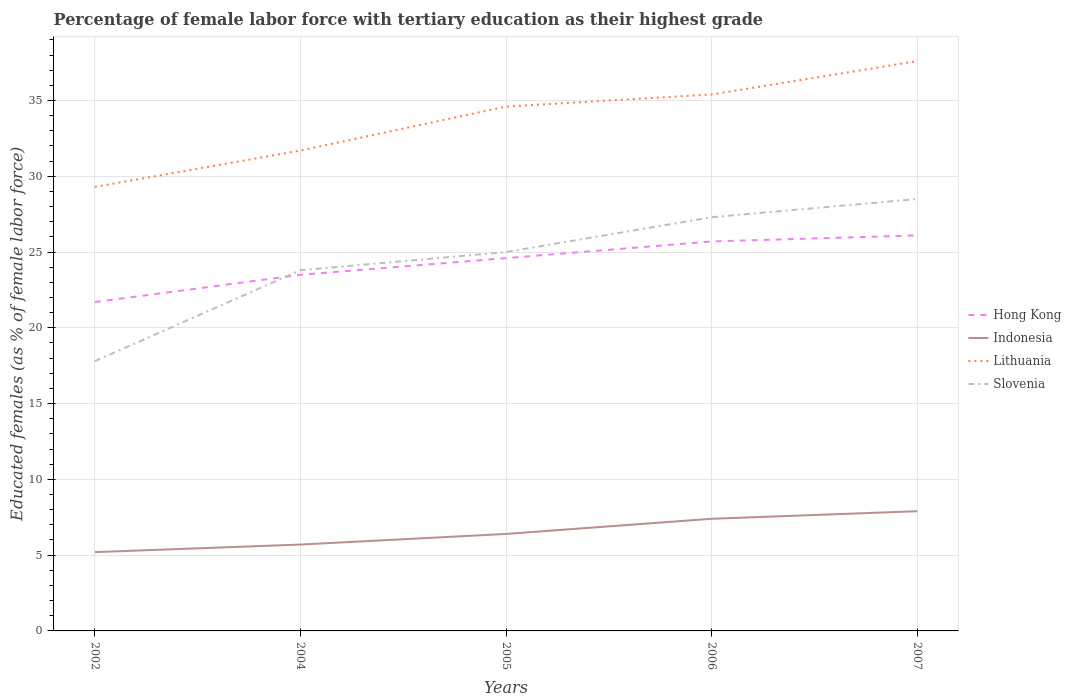How many different coloured lines are there?
Make the answer very short. 4. Does the line corresponding to Lithuania intersect with the line corresponding to Hong Kong?
Make the answer very short. No. Across all years, what is the maximum percentage of female labor force with tertiary education in Slovenia?
Give a very brief answer. 17.8. In which year was the percentage of female labor force with tertiary education in Lithuania maximum?
Your response must be concise. 2002. What is the total percentage of female labor force with tertiary education in Hong Kong in the graph?
Ensure brevity in your answer.  -1.8. What is the difference between the highest and the second highest percentage of female labor force with tertiary education in Hong Kong?
Ensure brevity in your answer.  4.4. Is the percentage of female labor force with tertiary education in Hong Kong strictly greater than the percentage of female labor force with tertiary education in Lithuania over the years?
Your response must be concise. Yes. Are the values on the major ticks of Y-axis written in scientific E-notation?
Make the answer very short. No. Does the graph contain any zero values?
Your response must be concise. No. Where does the legend appear in the graph?
Your answer should be very brief. Center right. How many legend labels are there?
Give a very brief answer. 4. What is the title of the graph?
Provide a short and direct response. Percentage of female labor force with tertiary education as their highest grade. Does "Malaysia" appear as one of the legend labels in the graph?
Ensure brevity in your answer.  No. What is the label or title of the Y-axis?
Provide a succinct answer. Educated females (as % of female labor force). What is the Educated females (as % of female labor force) in Hong Kong in 2002?
Provide a succinct answer. 21.7. What is the Educated females (as % of female labor force) of Indonesia in 2002?
Offer a very short reply. 5.2. What is the Educated females (as % of female labor force) in Lithuania in 2002?
Give a very brief answer. 29.3. What is the Educated females (as % of female labor force) in Slovenia in 2002?
Your response must be concise. 17.8. What is the Educated females (as % of female labor force) in Indonesia in 2004?
Your response must be concise. 5.7. What is the Educated females (as % of female labor force) of Lithuania in 2004?
Your answer should be compact. 31.7. What is the Educated females (as % of female labor force) of Slovenia in 2004?
Provide a succinct answer. 23.8. What is the Educated females (as % of female labor force) in Hong Kong in 2005?
Give a very brief answer. 24.6. What is the Educated females (as % of female labor force) in Indonesia in 2005?
Provide a short and direct response. 6.4. What is the Educated females (as % of female labor force) of Lithuania in 2005?
Offer a very short reply. 34.6. What is the Educated females (as % of female labor force) in Hong Kong in 2006?
Offer a terse response. 25.7. What is the Educated females (as % of female labor force) of Indonesia in 2006?
Provide a succinct answer. 7.4. What is the Educated females (as % of female labor force) of Lithuania in 2006?
Offer a very short reply. 35.4. What is the Educated females (as % of female labor force) of Slovenia in 2006?
Your answer should be very brief. 27.3. What is the Educated females (as % of female labor force) of Hong Kong in 2007?
Your answer should be compact. 26.1. What is the Educated females (as % of female labor force) in Indonesia in 2007?
Your response must be concise. 7.9. What is the Educated females (as % of female labor force) of Lithuania in 2007?
Provide a succinct answer. 37.6. What is the Educated females (as % of female labor force) of Slovenia in 2007?
Your response must be concise. 28.5. Across all years, what is the maximum Educated females (as % of female labor force) in Hong Kong?
Make the answer very short. 26.1. Across all years, what is the maximum Educated females (as % of female labor force) in Indonesia?
Make the answer very short. 7.9. Across all years, what is the maximum Educated females (as % of female labor force) in Lithuania?
Ensure brevity in your answer.  37.6. Across all years, what is the minimum Educated females (as % of female labor force) in Hong Kong?
Your answer should be very brief. 21.7. Across all years, what is the minimum Educated females (as % of female labor force) in Indonesia?
Give a very brief answer. 5.2. Across all years, what is the minimum Educated females (as % of female labor force) in Lithuania?
Give a very brief answer. 29.3. Across all years, what is the minimum Educated females (as % of female labor force) of Slovenia?
Your answer should be very brief. 17.8. What is the total Educated females (as % of female labor force) in Hong Kong in the graph?
Make the answer very short. 121.6. What is the total Educated females (as % of female labor force) of Indonesia in the graph?
Keep it short and to the point. 32.6. What is the total Educated females (as % of female labor force) of Lithuania in the graph?
Offer a very short reply. 168.6. What is the total Educated females (as % of female labor force) in Slovenia in the graph?
Your answer should be compact. 122.4. What is the difference between the Educated females (as % of female labor force) in Indonesia in 2002 and that in 2004?
Your answer should be very brief. -0.5. What is the difference between the Educated females (as % of female labor force) in Slovenia in 2002 and that in 2004?
Make the answer very short. -6. What is the difference between the Educated females (as % of female labor force) in Lithuania in 2002 and that in 2005?
Provide a succinct answer. -5.3. What is the difference between the Educated females (as % of female labor force) of Slovenia in 2002 and that in 2006?
Your answer should be compact. -9.5. What is the difference between the Educated females (as % of female labor force) in Lithuania in 2002 and that in 2007?
Give a very brief answer. -8.3. What is the difference between the Educated females (as % of female labor force) in Slovenia in 2002 and that in 2007?
Offer a terse response. -10.7. What is the difference between the Educated females (as % of female labor force) of Hong Kong in 2004 and that in 2005?
Provide a succinct answer. -1.1. What is the difference between the Educated females (as % of female labor force) in Lithuania in 2004 and that in 2005?
Offer a terse response. -2.9. What is the difference between the Educated females (as % of female labor force) in Slovenia in 2004 and that in 2005?
Give a very brief answer. -1.2. What is the difference between the Educated females (as % of female labor force) of Hong Kong in 2004 and that in 2006?
Provide a succinct answer. -2.2. What is the difference between the Educated females (as % of female labor force) in Indonesia in 2004 and that in 2006?
Provide a short and direct response. -1.7. What is the difference between the Educated females (as % of female labor force) in Lithuania in 2004 and that in 2006?
Offer a very short reply. -3.7. What is the difference between the Educated females (as % of female labor force) of Hong Kong in 2004 and that in 2007?
Keep it short and to the point. -2.6. What is the difference between the Educated females (as % of female labor force) of Indonesia in 2004 and that in 2007?
Provide a succinct answer. -2.2. What is the difference between the Educated females (as % of female labor force) of Lithuania in 2004 and that in 2007?
Your response must be concise. -5.9. What is the difference between the Educated females (as % of female labor force) in Slovenia in 2004 and that in 2007?
Your response must be concise. -4.7. What is the difference between the Educated females (as % of female labor force) in Indonesia in 2005 and that in 2006?
Make the answer very short. -1. What is the difference between the Educated females (as % of female labor force) of Lithuania in 2005 and that in 2006?
Your answer should be compact. -0.8. What is the difference between the Educated females (as % of female labor force) of Lithuania in 2005 and that in 2007?
Provide a succinct answer. -3. What is the difference between the Educated females (as % of female labor force) of Slovenia in 2005 and that in 2007?
Your response must be concise. -3.5. What is the difference between the Educated females (as % of female labor force) in Hong Kong in 2006 and that in 2007?
Make the answer very short. -0.4. What is the difference between the Educated females (as % of female labor force) in Lithuania in 2006 and that in 2007?
Make the answer very short. -2.2. What is the difference between the Educated females (as % of female labor force) in Indonesia in 2002 and the Educated females (as % of female labor force) in Lithuania in 2004?
Keep it short and to the point. -26.5. What is the difference between the Educated females (as % of female labor force) in Indonesia in 2002 and the Educated females (as % of female labor force) in Slovenia in 2004?
Provide a succinct answer. -18.6. What is the difference between the Educated females (as % of female labor force) in Lithuania in 2002 and the Educated females (as % of female labor force) in Slovenia in 2004?
Ensure brevity in your answer.  5.5. What is the difference between the Educated females (as % of female labor force) in Hong Kong in 2002 and the Educated females (as % of female labor force) in Slovenia in 2005?
Your answer should be compact. -3.3. What is the difference between the Educated females (as % of female labor force) of Indonesia in 2002 and the Educated females (as % of female labor force) of Lithuania in 2005?
Give a very brief answer. -29.4. What is the difference between the Educated females (as % of female labor force) in Indonesia in 2002 and the Educated females (as % of female labor force) in Slovenia in 2005?
Give a very brief answer. -19.8. What is the difference between the Educated females (as % of female labor force) of Lithuania in 2002 and the Educated females (as % of female labor force) of Slovenia in 2005?
Your answer should be compact. 4.3. What is the difference between the Educated females (as % of female labor force) in Hong Kong in 2002 and the Educated females (as % of female labor force) in Indonesia in 2006?
Offer a very short reply. 14.3. What is the difference between the Educated females (as % of female labor force) in Hong Kong in 2002 and the Educated females (as % of female labor force) in Lithuania in 2006?
Ensure brevity in your answer.  -13.7. What is the difference between the Educated females (as % of female labor force) in Indonesia in 2002 and the Educated females (as % of female labor force) in Lithuania in 2006?
Provide a succinct answer. -30.2. What is the difference between the Educated females (as % of female labor force) of Indonesia in 2002 and the Educated females (as % of female labor force) of Slovenia in 2006?
Offer a very short reply. -22.1. What is the difference between the Educated females (as % of female labor force) of Hong Kong in 2002 and the Educated females (as % of female labor force) of Lithuania in 2007?
Provide a short and direct response. -15.9. What is the difference between the Educated females (as % of female labor force) in Indonesia in 2002 and the Educated females (as % of female labor force) in Lithuania in 2007?
Make the answer very short. -32.4. What is the difference between the Educated females (as % of female labor force) in Indonesia in 2002 and the Educated females (as % of female labor force) in Slovenia in 2007?
Your response must be concise. -23.3. What is the difference between the Educated females (as % of female labor force) in Hong Kong in 2004 and the Educated females (as % of female labor force) in Indonesia in 2005?
Your answer should be compact. 17.1. What is the difference between the Educated females (as % of female labor force) of Indonesia in 2004 and the Educated females (as % of female labor force) of Lithuania in 2005?
Your answer should be compact. -28.9. What is the difference between the Educated females (as % of female labor force) in Indonesia in 2004 and the Educated females (as % of female labor force) in Slovenia in 2005?
Make the answer very short. -19.3. What is the difference between the Educated females (as % of female labor force) in Lithuania in 2004 and the Educated females (as % of female labor force) in Slovenia in 2005?
Provide a succinct answer. 6.7. What is the difference between the Educated females (as % of female labor force) of Hong Kong in 2004 and the Educated females (as % of female labor force) of Lithuania in 2006?
Provide a succinct answer. -11.9. What is the difference between the Educated females (as % of female labor force) in Hong Kong in 2004 and the Educated females (as % of female labor force) in Slovenia in 2006?
Provide a succinct answer. -3.8. What is the difference between the Educated females (as % of female labor force) in Indonesia in 2004 and the Educated females (as % of female labor force) in Lithuania in 2006?
Offer a very short reply. -29.7. What is the difference between the Educated females (as % of female labor force) of Indonesia in 2004 and the Educated females (as % of female labor force) of Slovenia in 2006?
Keep it short and to the point. -21.6. What is the difference between the Educated females (as % of female labor force) of Hong Kong in 2004 and the Educated females (as % of female labor force) of Lithuania in 2007?
Offer a very short reply. -14.1. What is the difference between the Educated females (as % of female labor force) in Indonesia in 2004 and the Educated females (as % of female labor force) in Lithuania in 2007?
Offer a very short reply. -31.9. What is the difference between the Educated females (as % of female labor force) in Indonesia in 2004 and the Educated females (as % of female labor force) in Slovenia in 2007?
Ensure brevity in your answer.  -22.8. What is the difference between the Educated females (as % of female labor force) in Hong Kong in 2005 and the Educated females (as % of female labor force) in Indonesia in 2006?
Keep it short and to the point. 17.2. What is the difference between the Educated females (as % of female labor force) of Hong Kong in 2005 and the Educated females (as % of female labor force) of Lithuania in 2006?
Provide a short and direct response. -10.8. What is the difference between the Educated females (as % of female labor force) in Hong Kong in 2005 and the Educated females (as % of female labor force) in Slovenia in 2006?
Provide a short and direct response. -2.7. What is the difference between the Educated females (as % of female labor force) in Indonesia in 2005 and the Educated females (as % of female labor force) in Slovenia in 2006?
Provide a short and direct response. -20.9. What is the difference between the Educated females (as % of female labor force) in Indonesia in 2005 and the Educated females (as % of female labor force) in Lithuania in 2007?
Ensure brevity in your answer.  -31.2. What is the difference between the Educated females (as % of female labor force) in Indonesia in 2005 and the Educated females (as % of female labor force) in Slovenia in 2007?
Offer a terse response. -22.1. What is the difference between the Educated females (as % of female labor force) of Hong Kong in 2006 and the Educated females (as % of female labor force) of Lithuania in 2007?
Your answer should be compact. -11.9. What is the difference between the Educated females (as % of female labor force) of Indonesia in 2006 and the Educated females (as % of female labor force) of Lithuania in 2007?
Offer a very short reply. -30.2. What is the difference between the Educated females (as % of female labor force) of Indonesia in 2006 and the Educated females (as % of female labor force) of Slovenia in 2007?
Your answer should be very brief. -21.1. What is the difference between the Educated females (as % of female labor force) of Lithuania in 2006 and the Educated females (as % of female labor force) of Slovenia in 2007?
Give a very brief answer. 6.9. What is the average Educated females (as % of female labor force) of Hong Kong per year?
Your answer should be very brief. 24.32. What is the average Educated females (as % of female labor force) in Indonesia per year?
Provide a succinct answer. 6.52. What is the average Educated females (as % of female labor force) of Lithuania per year?
Your answer should be very brief. 33.72. What is the average Educated females (as % of female labor force) in Slovenia per year?
Offer a terse response. 24.48. In the year 2002, what is the difference between the Educated females (as % of female labor force) in Hong Kong and Educated females (as % of female labor force) in Slovenia?
Your answer should be compact. 3.9. In the year 2002, what is the difference between the Educated females (as % of female labor force) in Indonesia and Educated females (as % of female labor force) in Lithuania?
Offer a terse response. -24.1. In the year 2002, what is the difference between the Educated females (as % of female labor force) in Indonesia and Educated females (as % of female labor force) in Slovenia?
Provide a short and direct response. -12.6. In the year 2004, what is the difference between the Educated females (as % of female labor force) of Hong Kong and Educated females (as % of female labor force) of Slovenia?
Provide a succinct answer. -0.3. In the year 2004, what is the difference between the Educated females (as % of female labor force) of Indonesia and Educated females (as % of female labor force) of Lithuania?
Offer a very short reply. -26. In the year 2004, what is the difference between the Educated females (as % of female labor force) of Indonesia and Educated females (as % of female labor force) of Slovenia?
Your response must be concise. -18.1. In the year 2005, what is the difference between the Educated females (as % of female labor force) in Hong Kong and Educated females (as % of female labor force) in Lithuania?
Your response must be concise. -10. In the year 2005, what is the difference between the Educated females (as % of female labor force) of Hong Kong and Educated females (as % of female labor force) of Slovenia?
Offer a very short reply. -0.4. In the year 2005, what is the difference between the Educated females (as % of female labor force) in Indonesia and Educated females (as % of female labor force) in Lithuania?
Your response must be concise. -28.2. In the year 2005, what is the difference between the Educated females (as % of female labor force) of Indonesia and Educated females (as % of female labor force) of Slovenia?
Your answer should be very brief. -18.6. In the year 2006, what is the difference between the Educated females (as % of female labor force) in Hong Kong and Educated females (as % of female labor force) in Indonesia?
Your answer should be very brief. 18.3. In the year 2006, what is the difference between the Educated females (as % of female labor force) of Hong Kong and Educated females (as % of female labor force) of Lithuania?
Keep it short and to the point. -9.7. In the year 2006, what is the difference between the Educated females (as % of female labor force) of Hong Kong and Educated females (as % of female labor force) of Slovenia?
Ensure brevity in your answer.  -1.6. In the year 2006, what is the difference between the Educated females (as % of female labor force) of Indonesia and Educated females (as % of female labor force) of Slovenia?
Your answer should be very brief. -19.9. In the year 2007, what is the difference between the Educated females (as % of female labor force) in Hong Kong and Educated females (as % of female labor force) in Indonesia?
Offer a terse response. 18.2. In the year 2007, what is the difference between the Educated females (as % of female labor force) in Hong Kong and Educated females (as % of female labor force) in Lithuania?
Ensure brevity in your answer.  -11.5. In the year 2007, what is the difference between the Educated females (as % of female labor force) of Indonesia and Educated females (as % of female labor force) of Lithuania?
Provide a short and direct response. -29.7. In the year 2007, what is the difference between the Educated females (as % of female labor force) in Indonesia and Educated females (as % of female labor force) in Slovenia?
Offer a very short reply. -20.6. In the year 2007, what is the difference between the Educated females (as % of female labor force) of Lithuania and Educated females (as % of female labor force) of Slovenia?
Your response must be concise. 9.1. What is the ratio of the Educated females (as % of female labor force) of Hong Kong in 2002 to that in 2004?
Your answer should be compact. 0.92. What is the ratio of the Educated females (as % of female labor force) of Indonesia in 2002 to that in 2004?
Offer a terse response. 0.91. What is the ratio of the Educated females (as % of female labor force) in Lithuania in 2002 to that in 2004?
Your answer should be compact. 0.92. What is the ratio of the Educated females (as % of female labor force) in Slovenia in 2002 to that in 2004?
Give a very brief answer. 0.75. What is the ratio of the Educated females (as % of female labor force) in Hong Kong in 2002 to that in 2005?
Your answer should be very brief. 0.88. What is the ratio of the Educated females (as % of female labor force) in Indonesia in 2002 to that in 2005?
Keep it short and to the point. 0.81. What is the ratio of the Educated females (as % of female labor force) in Lithuania in 2002 to that in 2005?
Your answer should be compact. 0.85. What is the ratio of the Educated females (as % of female labor force) in Slovenia in 2002 to that in 2005?
Offer a terse response. 0.71. What is the ratio of the Educated females (as % of female labor force) of Hong Kong in 2002 to that in 2006?
Make the answer very short. 0.84. What is the ratio of the Educated females (as % of female labor force) of Indonesia in 2002 to that in 2006?
Keep it short and to the point. 0.7. What is the ratio of the Educated females (as % of female labor force) of Lithuania in 2002 to that in 2006?
Provide a succinct answer. 0.83. What is the ratio of the Educated females (as % of female labor force) of Slovenia in 2002 to that in 2006?
Offer a very short reply. 0.65. What is the ratio of the Educated females (as % of female labor force) of Hong Kong in 2002 to that in 2007?
Ensure brevity in your answer.  0.83. What is the ratio of the Educated females (as % of female labor force) in Indonesia in 2002 to that in 2007?
Your response must be concise. 0.66. What is the ratio of the Educated females (as % of female labor force) of Lithuania in 2002 to that in 2007?
Your answer should be very brief. 0.78. What is the ratio of the Educated females (as % of female labor force) in Slovenia in 2002 to that in 2007?
Your answer should be very brief. 0.62. What is the ratio of the Educated females (as % of female labor force) of Hong Kong in 2004 to that in 2005?
Provide a short and direct response. 0.96. What is the ratio of the Educated females (as % of female labor force) of Indonesia in 2004 to that in 2005?
Ensure brevity in your answer.  0.89. What is the ratio of the Educated females (as % of female labor force) of Lithuania in 2004 to that in 2005?
Give a very brief answer. 0.92. What is the ratio of the Educated females (as % of female labor force) of Slovenia in 2004 to that in 2005?
Your response must be concise. 0.95. What is the ratio of the Educated females (as % of female labor force) of Hong Kong in 2004 to that in 2006?
Your answer should be very brief. 0.91. What is the ratio of the Educated females (as % of female labor force) in Indonesia in 2004 to that in 2006?
Your answer should be compact. 0.77. What is the ratio of the Educated females (as % of female labor force) in Lithuania in 2004 to that in 2006?
Make the answer very short. 0.9. What is the ratio of the Educated females (as % of female labor force) in Slovenia in 2004 to that in 2006?
Ensure brevity in your answer.  0.87. What is the ratio of the Educated females (as % of female labor force) in Hong Kong in 2004 to that in 2007?
Offer a terse response. 0.9. What is the ratio of the Educated females (as % of female labor force) in Indonesia in 2004 to that in 2007?
Provide a short and direct response. 0.72. What is the ratio of the Educated females (as % of female labor force) in Lithuania in 2004 to that in 2007?
Make the answer very short. 0.84. What is the ratio of the Educated females (as % of female labor force) in Slovenia in 2004 to that in 2007?
Provide a short and direct response. 0.84. What is the ratio of the Educated females (as % of female labor force) of Hong Kong in 2005 to that in 2006?
Ensure brevity in your answer.  0.96. What is the ratio of the Educated females (as % of female labor force) of Indonesia in 2005 to that in 2006?
Your response must be concise. 0.86. What is the ratio of the Educated females (as % of female labor force) of Lithuania in 2005 to that in 2006?
Provide a short and direct response. 0.98. What is the ratio of the Educated females (as % of female labor force) in Slovenia in 2005 to that in 2006?
Provide a succinct answer. 0.92. What is the ratio of the Educated females (as % of female labor force) in Hong Kong in 2005 to that in 2007?
Make the answer very short. 0.94. What is the ratio of the Educated females (as % of female labor force) of Indonesia in 2005 to that in 2007?
Keep it short and to the point. 0.81. What is the ratio of the Educated females (as % of female labor force) of Lithuania in 2005 to that in 2007?
Offer a very short reply. 0.92. What is the ratio of the Educated females (as % of female labor force) of Slovenia in 2005 to that in 2007?
Offer a terse response. 0.88. What is the ratio of the Educated females (as % of female labor force) in Hong Kong in 2006 to that in 2007?
Your answer should be compact. 0.98. What is the ratio of the Educated females (as % of female labor force) of Indonesia in 2006 to that in 2007?
Keep it short and to the point. 0.94. What is the ratio of the Educated females (as % of female labor force) in Lithuania in 2006 to that in 2007?
Give a very brief answer. 0.94. What is the ratio of the Educated females (as % of female labor force) of Slovenia in 2006 to that in 2007?
Offer a very short reply. 0.96. What is the difference between the highest and the second highest Educated females (as % of female labor force) in Indonesia?
Offer a very short reply. 0.5. What is the difference between the highest and the lowest Educated females (as % of female labor force) in Indonesia?
Give a very brief answer. 2.7. What is the difference between the highest and the lowest Educated females (as % of female labor force) of Slovenia?
Provide a succinct answer. 10.7. 